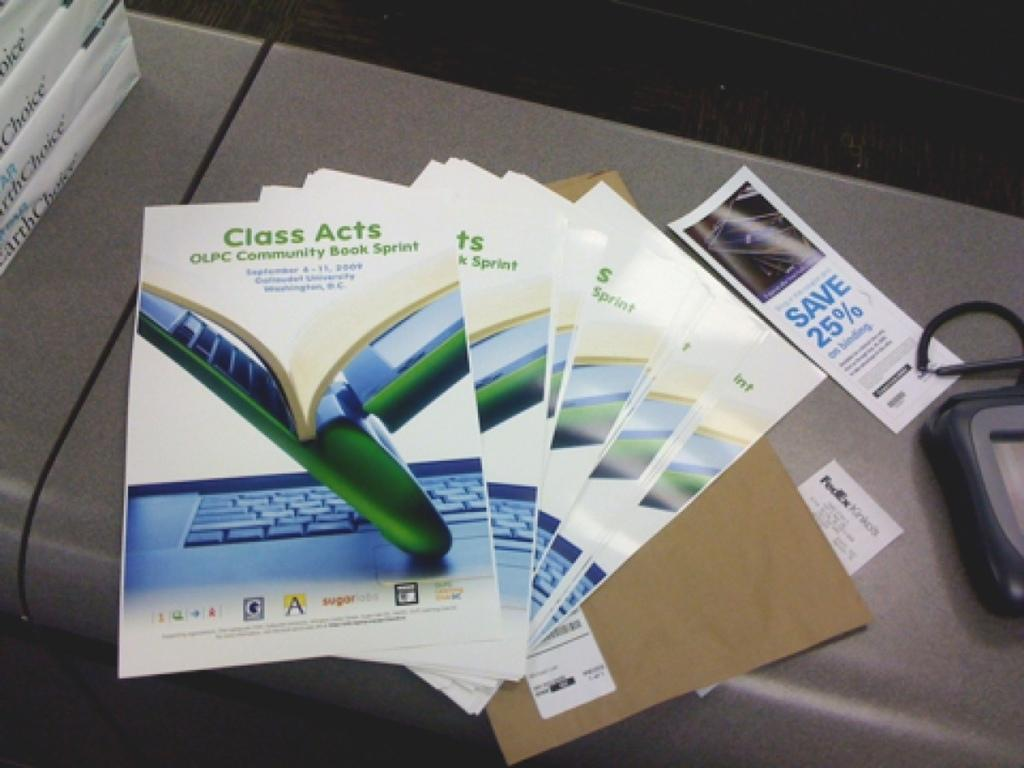<image>
Provide a brief description of the given image. Class Acts Brochures from the OLPC Community Book Sprint. 